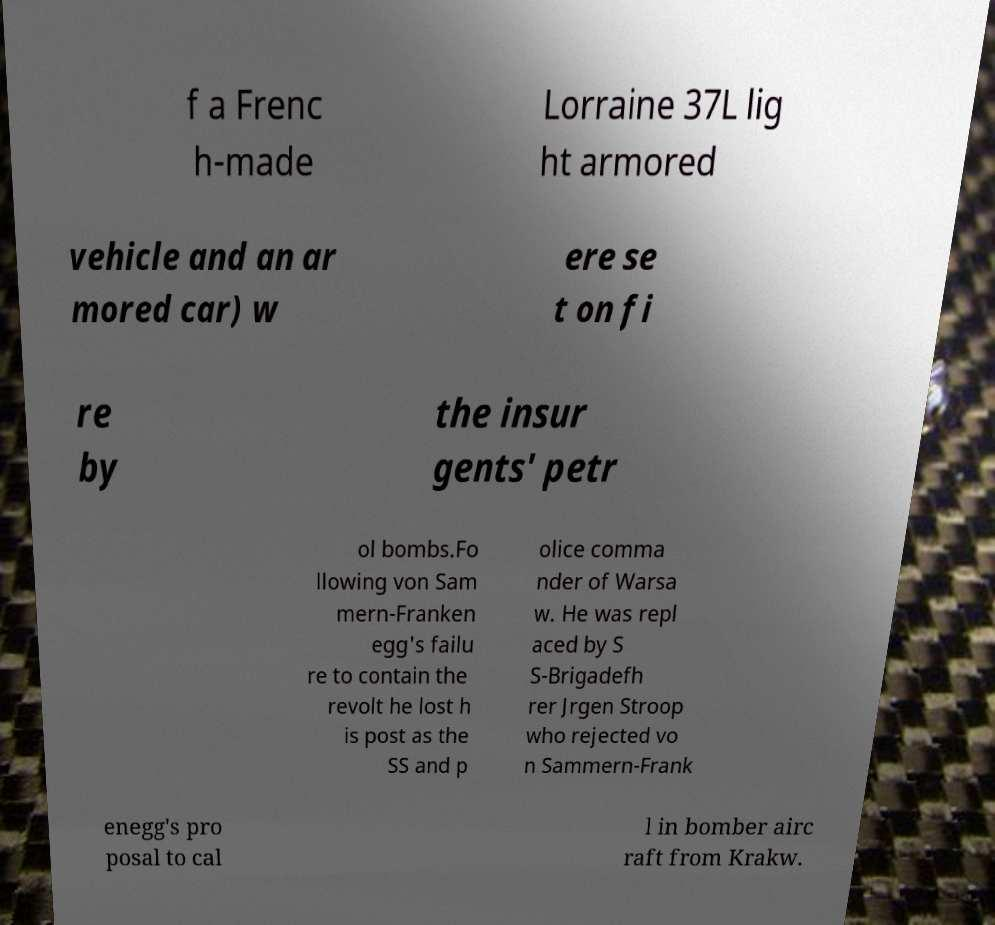What messages or text are displayed in this image? I need them in a readable, typed format. f a Frenc h-made Lorraine 37L lig ht armored vehicle and an ar mored car) w ere se t on fi re by the insur gents' petr ol bombs.Fo llowing von Sam mern-Franken egg's failu re to contain the revolt he lost h is post as the SS and p olice comma nder of Warsa w. He was repl aced by S S-Brigadefh rer Jrgen Stroop who rejected vo n Sammern-Frank enegg's pro posal to cal l in bomber airc raft from Krakw. 